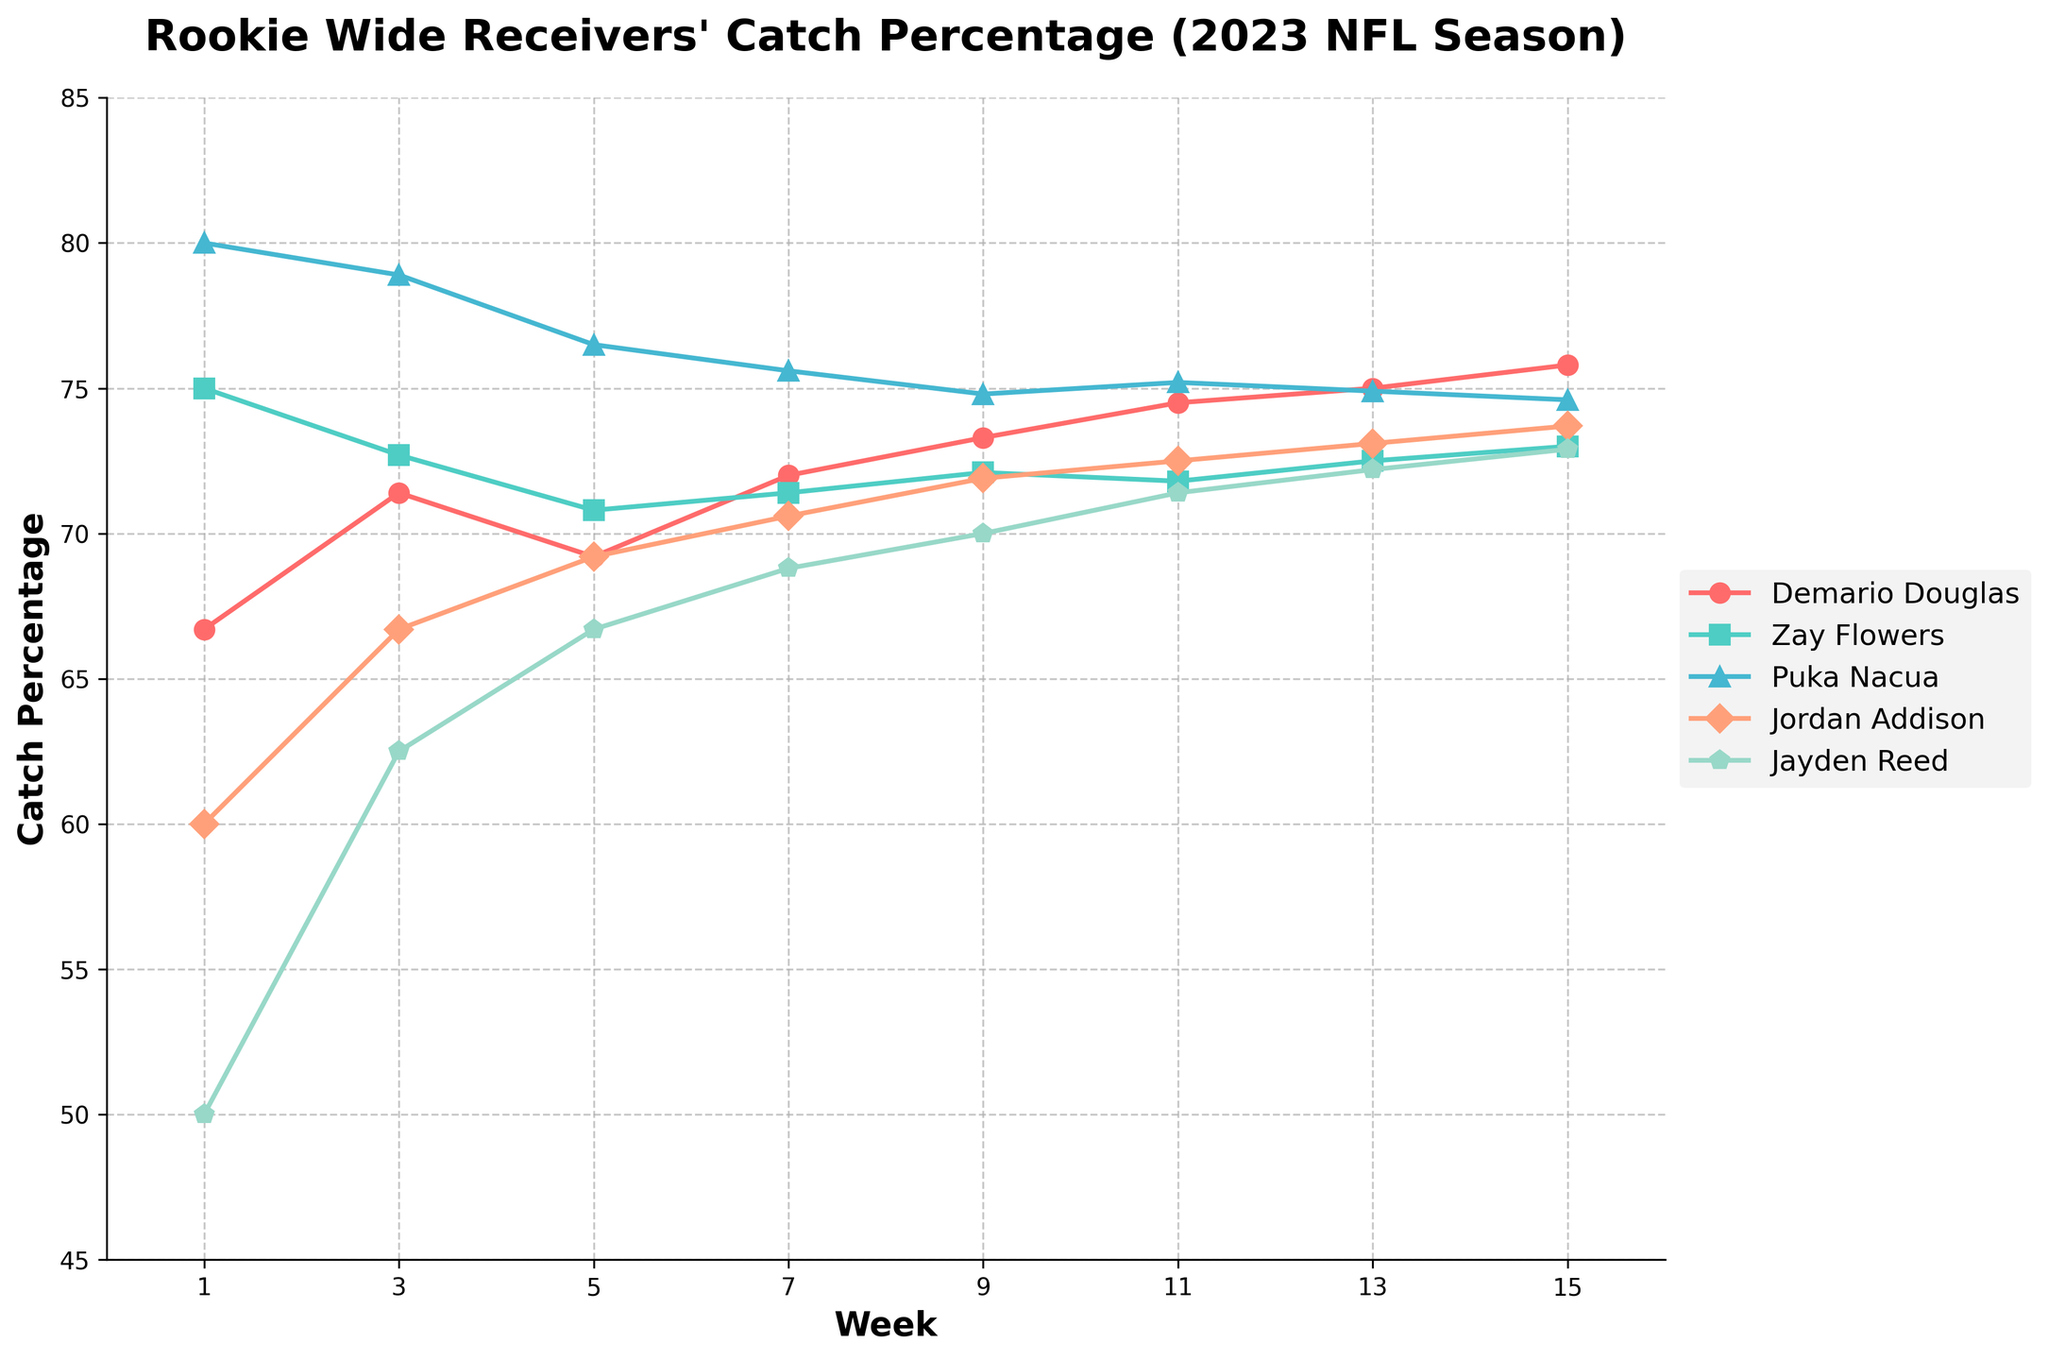what is the title of the figure? The title is written at the top of the figure in bold text. It is meant to convey the overall subject or focus of the chart.
Answer: Rookie Wide Receivers' Catch Percentage (2023 NFL Season) Which wide receiver had the highest catch percentage in Week 1? Look at the data points for the catch percentages in Week 1 for all the wide receivers. Identify the highest value and the corresponding wide receiver.
Answer: Puka Nacua How did Demario Douglas's catch percentage change from Week 3 to Week 5? Observe Demario Douglas's data points for Week 3 and Week 5. Subtract the catch percentage in Week 3 from that in Week 5.
Answer: It decreased by 2.2% What is the general trend of Jayden Reed's catch percentage over the weeks? Examine Jayden Reed’s data points and observe if the values are generally increasing, decreasing, or fluctuating.
Answer: Generally increasing Which wide receiver had a catch percentage consistently above 70% from Week 1 to Week 15? Look at the catch percentages of each wide receiver across all the weeks from Week 1 to Week 15 and identify the one consistently above 70%.
Answer: Puka Nacua In which week did Demario Douglas's catch percentage surpass Zay Flowers's for the first time? Compare the catch percentages of Demario Douglas and Zay Flowers week by week and identify the first week where Douglas's catch percentage is higher.
Answer: Week 5 What is the average catch percentage of Jordan Addison over the 2023 NFL season? Sum all the data points for Jordan Addison's catch percentage from Week 1 to Week 15 and divide by the number of weeks.
Answer: 69.6% How do the catch percentages of Jayden Reed and Zay Flowers compare in Week 13? Look at Week 13's data points for Jayden Reed and Zay Flowers and compare the values to see which is higher or if they are equal.
Answer: Jayden Reed: 72.2%, Zay Flowers: 72.5%, so Zay Flowers's catch percentage is higher What can you infer about Puka Nacua's catch percentage trend between Week 1 and Week 15? Analyze Puka Nacua's data points from Week 1 to Week 15 to identify whether the catch percentage is generally increasing, decreasing, or remaining steady.
Answer: Slightly decreasing Which rookie wide receiver shows the most significant improvement in catch percentage from Week 1 to Week 15? Calculate the difference between the catch percentages for Week 1 and Week 15 for each wide receiver and identify the highest improvement.
Answer: Jayden Reed (22.9%) 